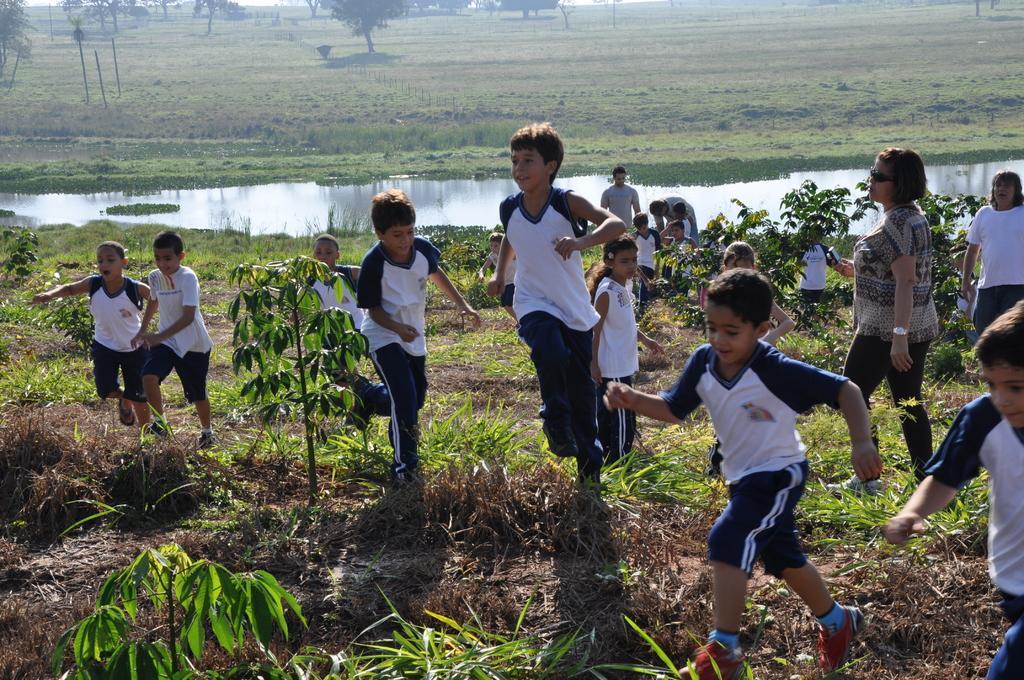How would you summarize this image in a sentence or two? In this image there are kids running on the land having some grass and plants. Few people are on the land. Middle of the image there is water. Top of the image there are trees on the land. 